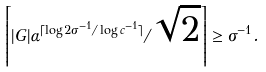<formula> <loc_0><loc_0><loc_500><loc_500>\left \lceil | G | \alpha ^ { \lceil \log 2 \sigma ^ { - 1 } / \log c ^ { - 1 } \rceil } / \sqrt { 2 } \right \rceil \geq \sigma ^ { - 1 } .</formula> 